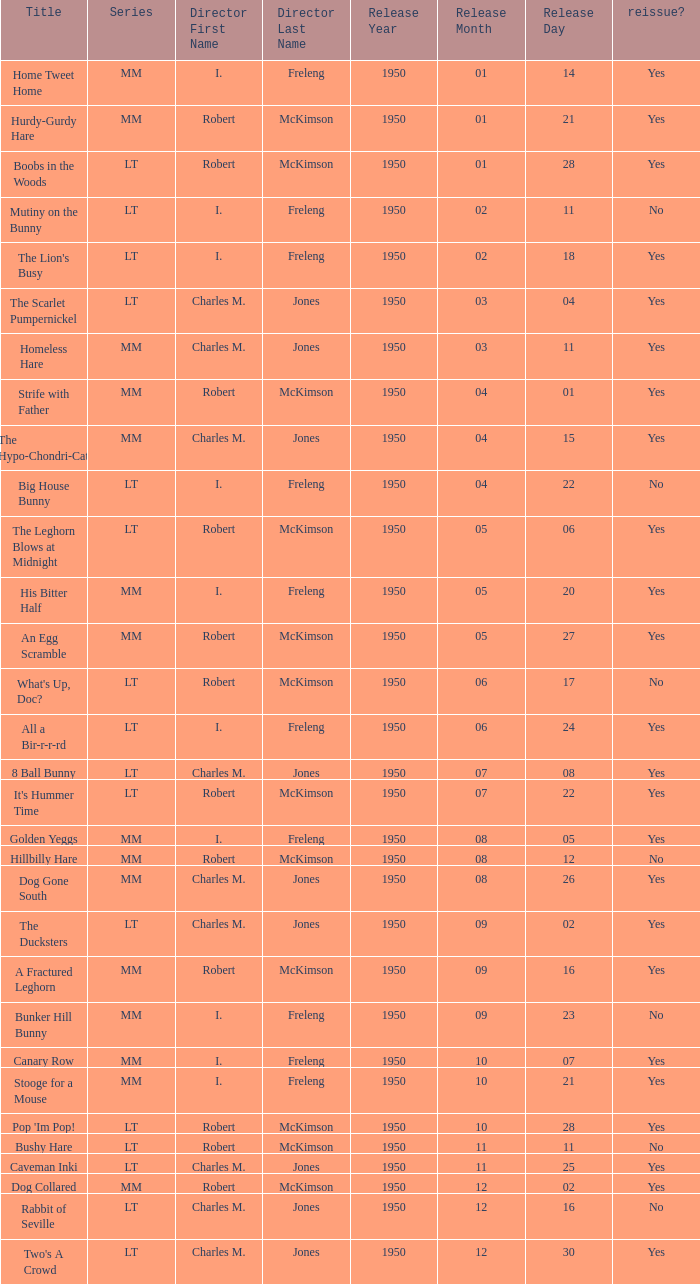Who directed Bunker Hill Bunny? I. Freleng. 